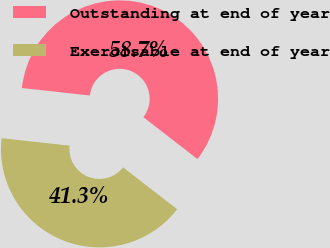<chart> <loc_0><loc_0><loc_500><loc_500><pie_chart><fcel>Outstanding at end of year<fcel>Exercisable at end of year<nl><fcel>58.74%<fcel>41.26%<nl></chart> 